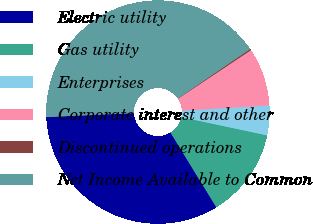Convert chart to OTSL. <chart><loc_0><loc_0><loc_500><loc_500><pie_chart><fcel>Electric utility<fcel>Gas utility<fcel>Enterprises<fcel>Corporate interest and other<fcel>Discontinued operations<fcel>Net Income Available to Common<nl><fcel>33.04%<fcel>12.9%<fcel>4.3%<fcel>8.39%<fcel>0.2%<fcel>41.17%<nl></chart> 